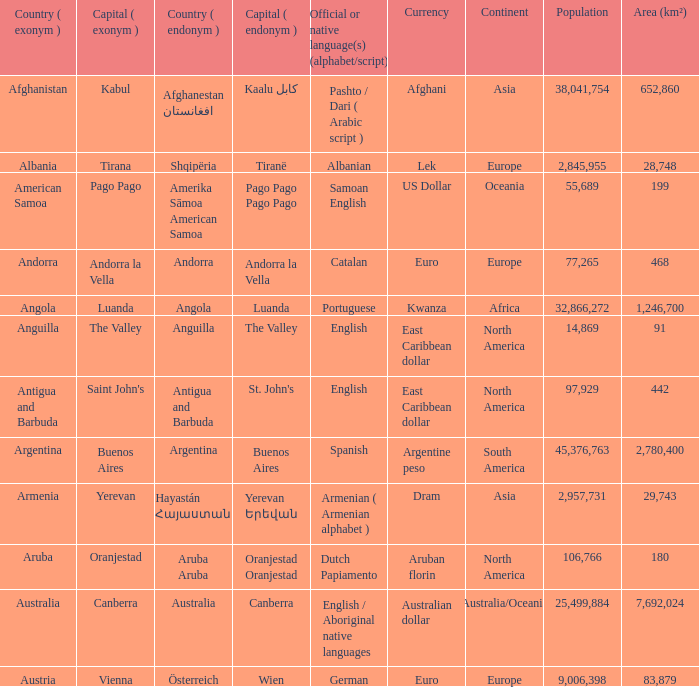How many capital cities does Australia have? 1.0. 